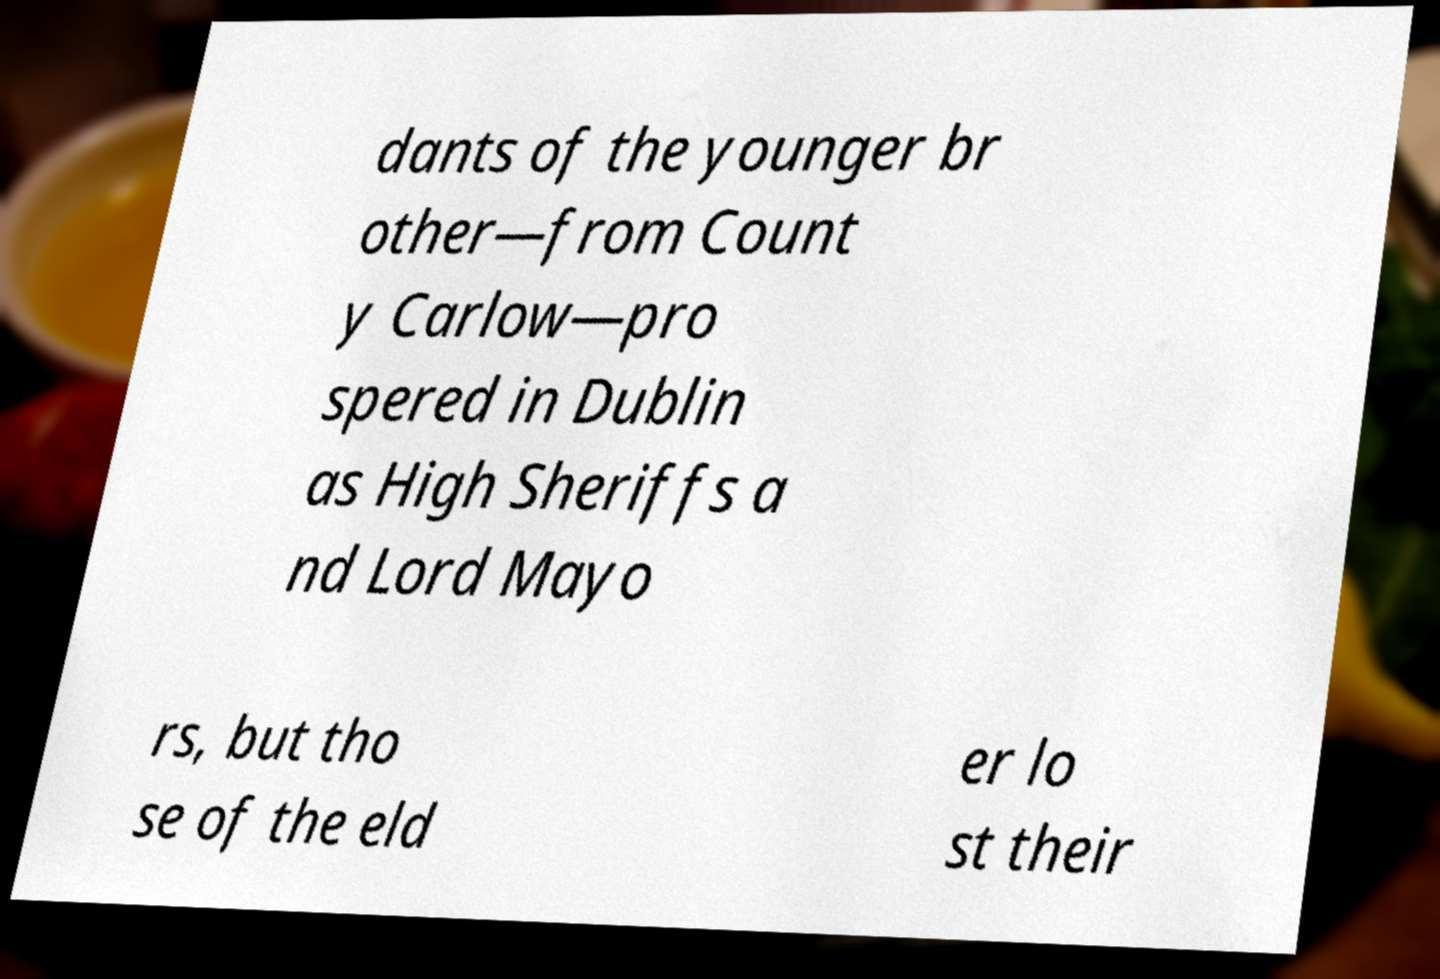What messages or text are displayed in this image? I need them in a readable, typed format. dants of the younger br other—from Count y Carlow—pro spered in Dublin as High Sheriffs a nd Lord Mayo rs, but tho se of the eld er lo st their 